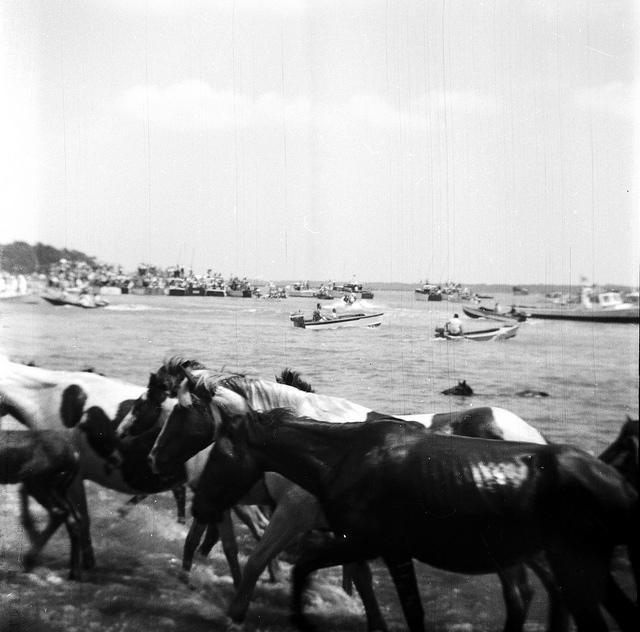Is this a rodeo?
Concise answer only. No. How many animals are shown?
Keep it brief. 5. What animal is this?
Keep it brief. Horse. 